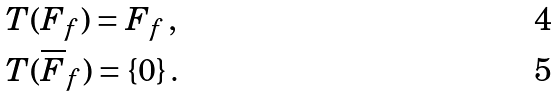Convert formula to latex. <formula><loc_0><loc_0><loc_500><loc_500>& T ( F _ { f } ) = F _ { f } \, , \\ & T ( \overline { F } _ { f } ) = \{ 0 \} \, .</formula> 